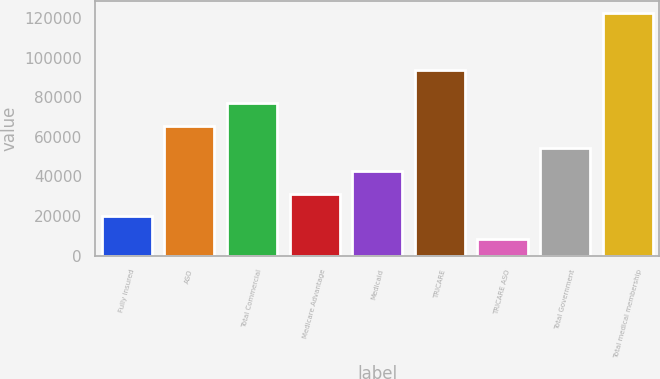Convert chart to OTSL. <chart><loc_0><loc_0><loc_500><loc_500><bar_chart><fcel>Fully insured<fcel>ASO<fcel>Total Commercial<fcel>Medicare Advantage<fcel>Medicaid<fcel>TRICARE<fcel>TRICARE ASO<fcel>Total Government<fcel>Total medical membership<nl><fcel>19900<fcel>65500<fcel>76900<fcel>31300<fcel>42700<fcel>93900<fcel>8500<fcel>54100<fcel>122500<nl></chart> 